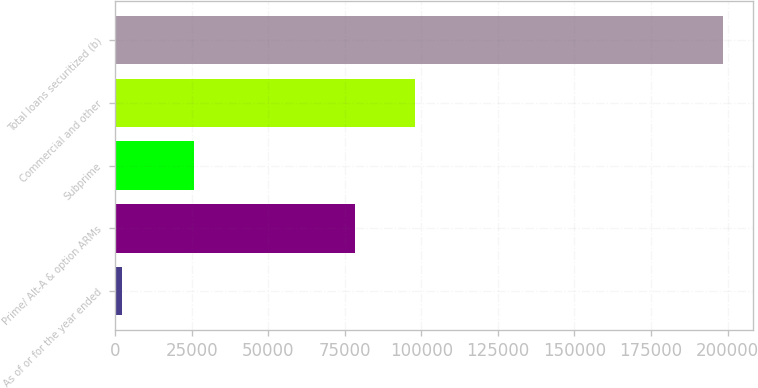Convert chart. <chart><loc_0><loc_0><loc_500><loc_500><bar_chart><fcel>As of or for the year ended<fcel>Prime/ Alt-A & option ARMs<fcel>Subprime<fcel>Commercial and other<fcel>Total loans securitized (b)<nl><fcel>2014<fcel>78294<fcel>25659<fcel>97931.7<fcel>198391<nl></chart> 